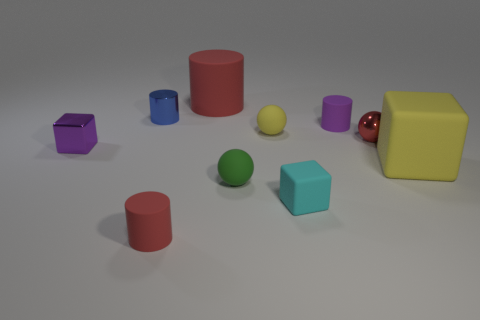There is a object that is behind the blue cylinder; is its color the same as the tiny matte cylinder to the left of the tiny purple matte cylinder?
Offer a very short reply. Yes. There is a small shiny object that is to the right of the small cylinder that is in front of the tiny metal cube; are there any rubber cubes that are right of it?
Your answer should be compact. Yes. What number of big blue matte cylinders are there?
Offer a terse response. 0. How many things are either big red matte cylinders that are right of the tiny red cylinder or small cylinders in front of the small blue cylinder?
Offer a very short reply. 3. There is a purple object right of the blue cylinder; is its size the same as the yellow block?
Provide a succinct answer. No. What is the size of the other red rubber object that is the same shape as the tiny red matte thing?
Provide a short and direct response. Large. There is a red cylinder that is the same size as the red shiny ball; what material is it?
Offer a terse response. Rubber. There is a tiny yellow thing that is the same shape as the green matte object; what material is it?
Make the answer very short. Rubber. What number of other things are there of the same size as the cyan object?
Your response must be concise. 7. The matte object that is the same color as the big cube is what size?
Provide a succinct answer. Small. 